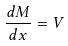<formula> <loc_0><loc_0><loc_500><loc_500>\frac { d M } { d x } = V</formula> 